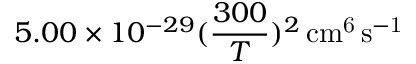<formula> <loc_0><loc_0><loc_500><loc_500>5 . 0 0 \times 1 0 ^ { - 2 9 } ( \frac { 3 0 0 } { T } ) ^ { 2 } \, c m ^ { 6 } \, s ^ { - 1 }</formula> 